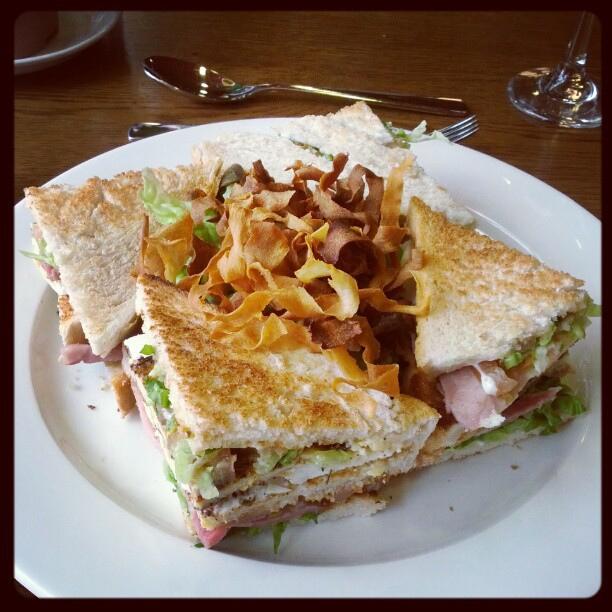What is the spoon on?
Concise answer only. Table. What is in the bread?
Keep it brief. Meat. Is the bread toasted?
Write a very short answer. Yes. Is there any soup on the table?
Answer briefly. No. 